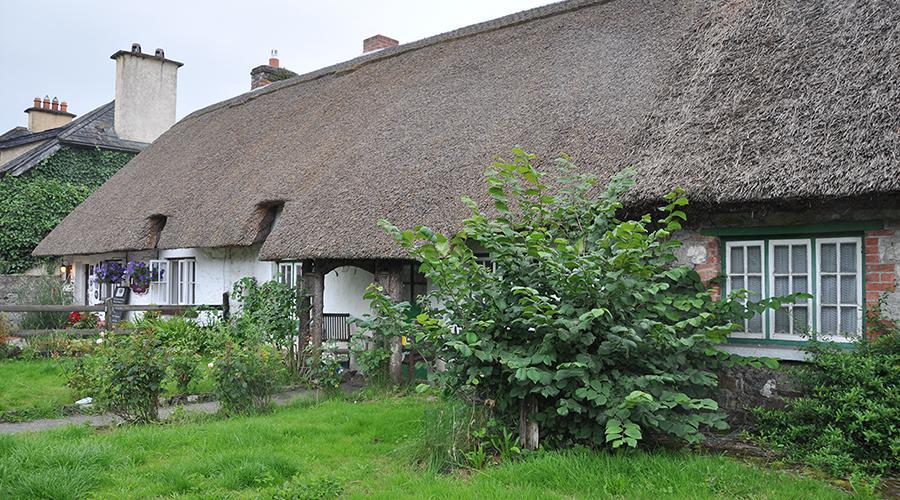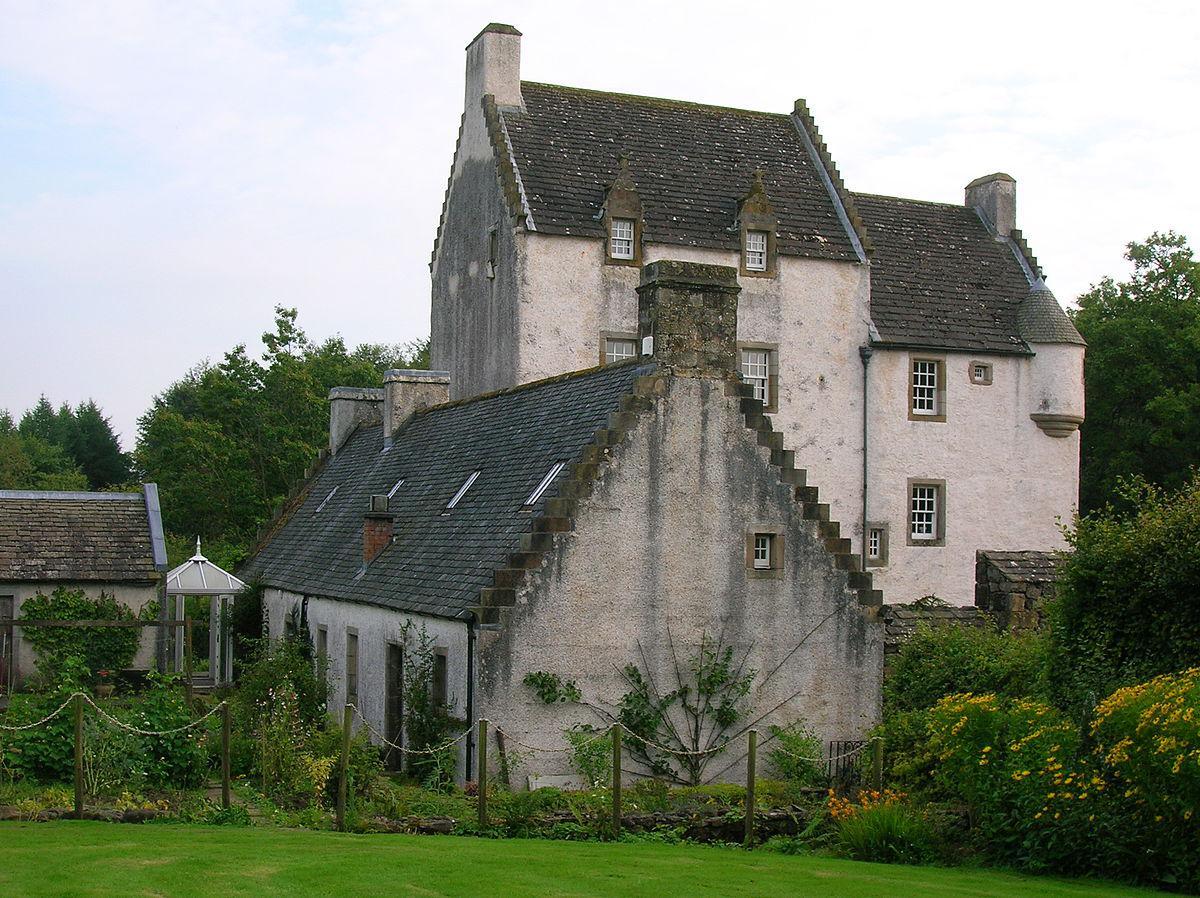The first image is the image on the left, the second image is the image on the right. Analyze the images presented: Is the assertion "A fence is put up around the house on the right." valid? Answer yes or no. Yes. The first image is the image on the left, the second image is the image on the right. Assess this claim about the two images: "There are fewer than five chimneys.". Correct or not? Answer yes or no. No. 